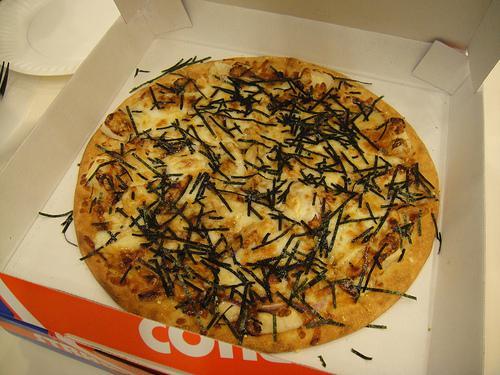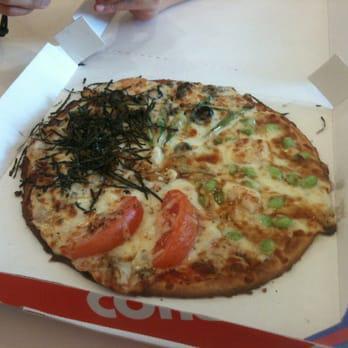The first image is the image on the left, the second image is the image on the right. Assess this claim about the two images: "The left and right image contains the same number of circle shaped pizzas.". Correct or not? Answer yes or no. Yes. The first image is the image on the left, the second image is the image on the right. For the images displayed, is the sentence "Each image contains exactly one rounded pizza with no slices missing." factually correct? Answer yes or no. Yes. 